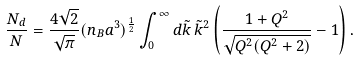Convert formula to latex. <formula><loc_0><loc_0><loc_500><loc_500>\frac { N _ { d } } { N } & = \frac { 4 \sqrt { 2 } } { \sqrt { \pi } } ( n _ { B } a ^ { 3 } ) ^ { \frac { 1 } { 2 } } \int _ { 0 } ^ { \infty } d \tilde { k } \, \tilde { k } ^ { 2 } \left ( \frac { 1 + Q ^ { 2 } } { \sqrt { Q ^ { 2 } ( Q ^ { 2 } + 2 ) } } - 1 \right ) .</formula> 